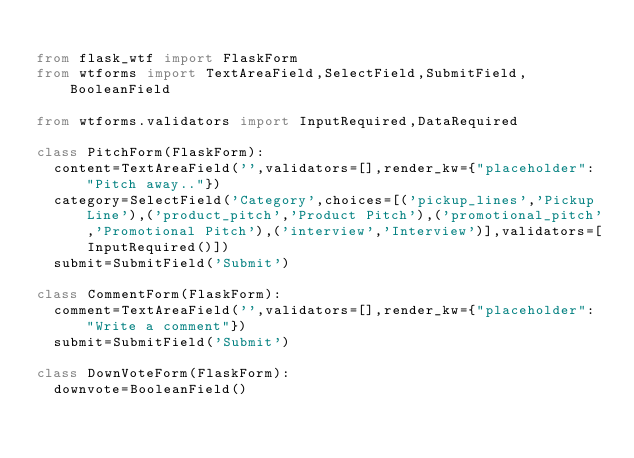<code> <loc_0><loc_0><loc_500><loc_500><_Python_>
from flask_wtf import FlaskForm
from wtforms import TextAreaField,SelectField,SubmitField,BooleanField

from wtforms.validators import InputRequired,DataRequired

class PitchForm(FlaskForm):
  content=TextAreaField('',validators=[],render_kw={"placeholder": "Pitch away.."})
  category=SelectField('Category',choices=[('pickup_lines','Pickup Line'),('product_pitch','Product Pitch'),('promotional_pitch','Promotional Pitch'),('interview','Interview')],validators=[InputRequired()])
  submit=SubmitField('Submit')

class CommentForm(FlaskForm):
  comment=TextAreaField('',validators=[],render_kw={"placeholder": "Write a comment"})
  submit=SubmitField('Submit')

class DownVoteForm(FlaskForm):
  downvote=BooleanField()</code> 